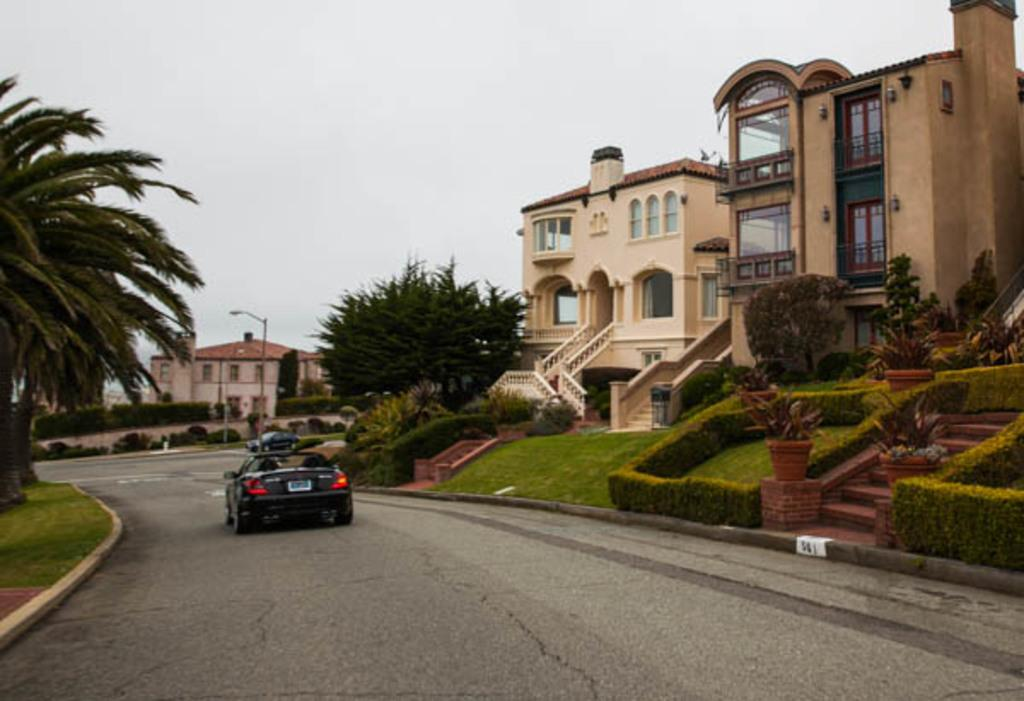What can be seen on the road in the image? There are vehicles on the road in the image. What type of vegetation is present in the image? There are plants, grass, and trees in the image. What type of structures can be seen in the image? There are buildings in the image. What is visible in the background of the image? The sky is visible in the background of the image. What religion is being practiced in the image? There is no indication of any religious practice in the image. How can the distance between the buildings be measured in the image? The image is a static representation and cannot be used to measure distances. 